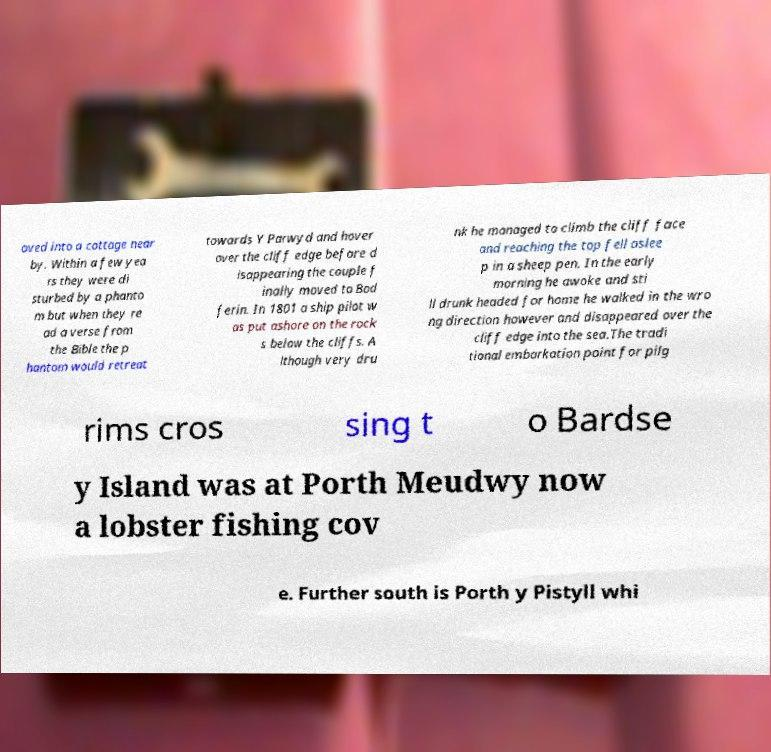For documentation purposes, I need the text within this image transcribed. Could you provide that? oved into a cottage near by. Within a few yea rs they were di sturbed by a phanto m but when they re ad a verse from the Bible the p hantom would retreat towards Y Parwyd and hover over the cliff edge before d isappearing the couple f inally moved to Bod ferin. In 1801 a ship pilot w as put ashore on the rock s below the cliffs. A lthough very dru nk he managed to climb the cliff face and reaching the top fell aslee p in a sheep pen. In the early morning he awoke and sti ll drunk headed for home he walked in the wro ng direction however and disappeared over the cliff edge into the sea.The tradi tional embarkation point for pilg rims cros sing t o Bardse y Island was at Porth Meudwy now a lobster fishing cov e. Further south is Porth y Pistyll whi 